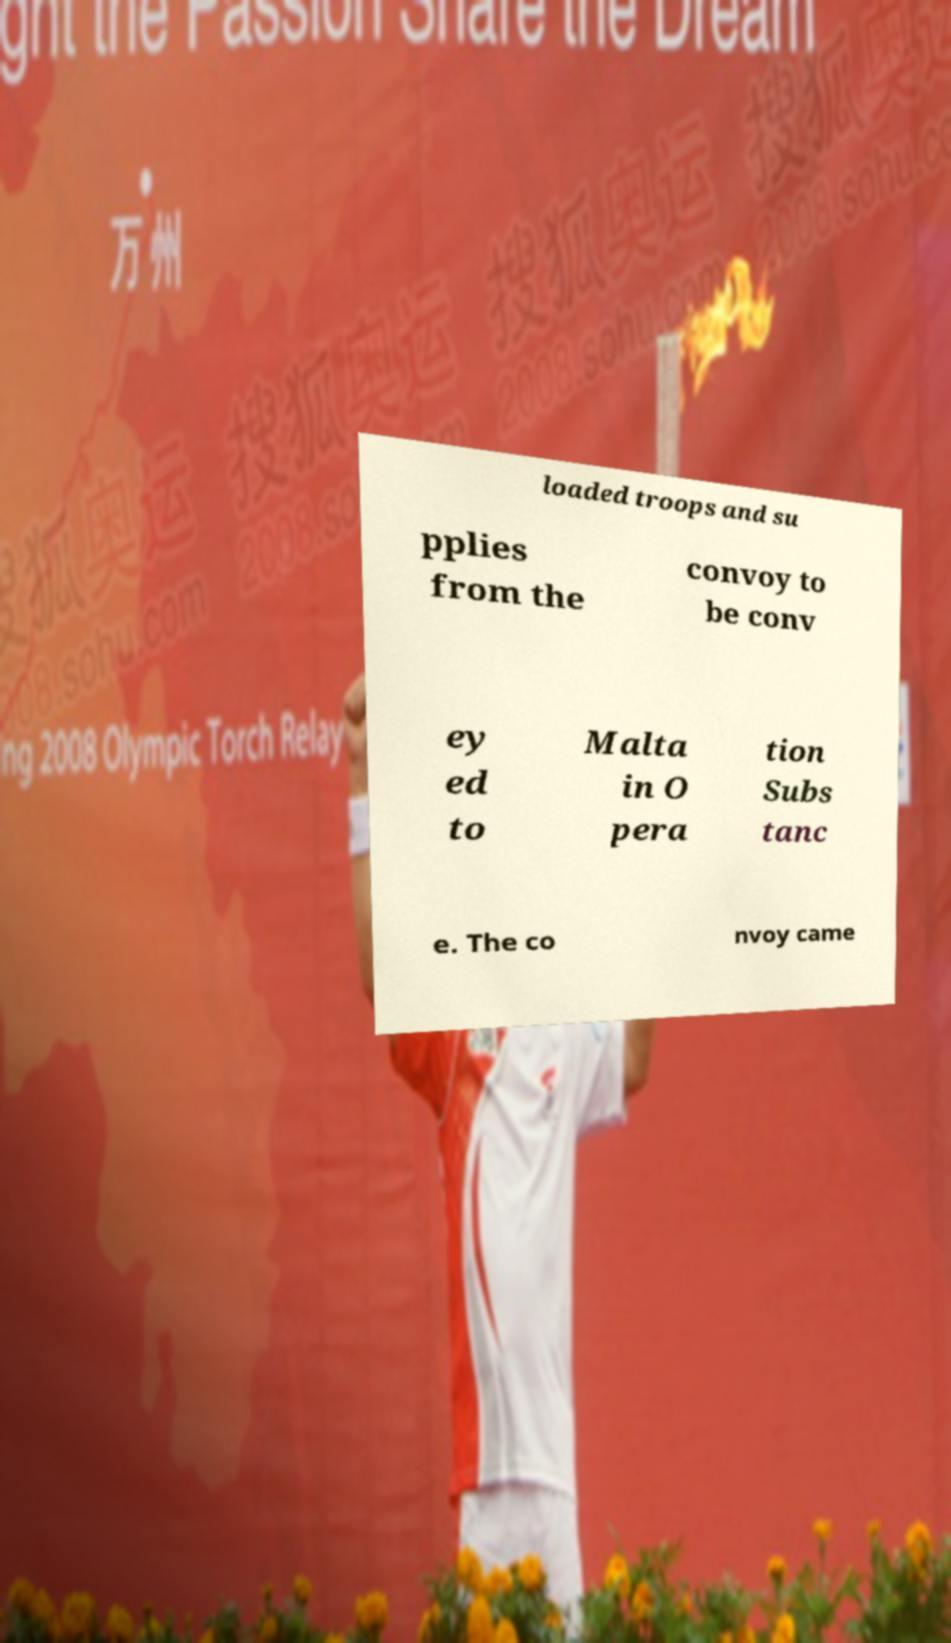There's text embedded in this image that I need extracted. Can you transcribe it verbatim? loaded troops and su pplies from the convoy to be conv ey ed to Malta in O pera tion Subs tanc e. The co nvoy came 